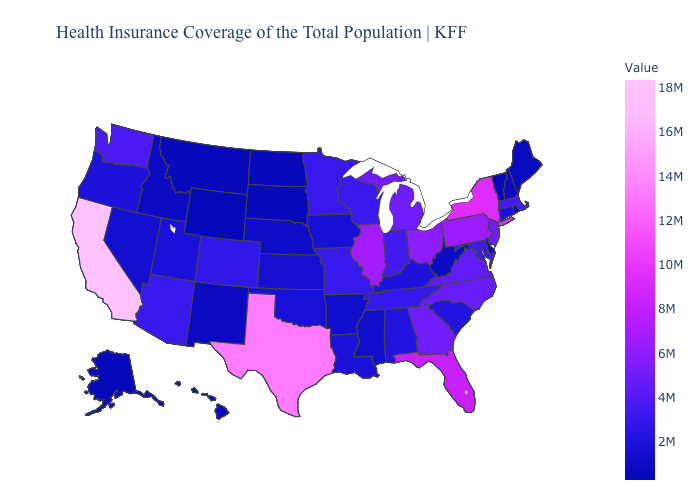Among the states that border Pennsylvania , does New York have the highest value?
Answer briefly. Yes. Which states have the highest value in the USA?
Answer briefly. California. Does the map have missing data?
Keep it brief. No. Does Alaska have a lower value than Illinois?
Answer briefly. Yes. 